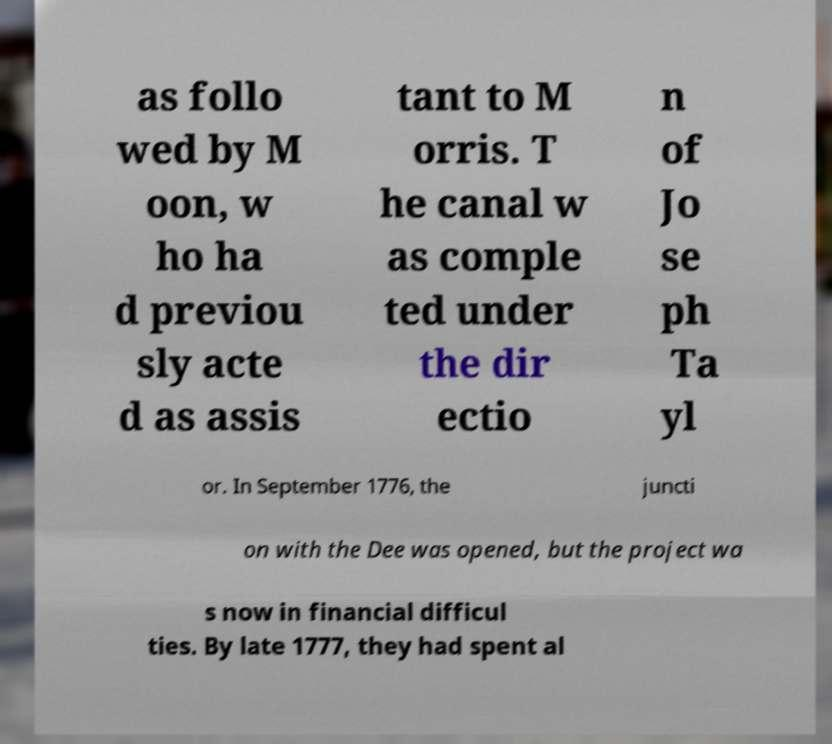Please identify and transcribe the text found in this image. as follo wed by M oon, w ho ha d previou sly acte d as assis tant to M orris. T he canal w as comple ted under the dir ectio n of Jo se ph Ta yl or. In September 1776, the juncti on with the Dee was opened, but the project wa s now in financial difficul ties. By late 1777, they had spent al 